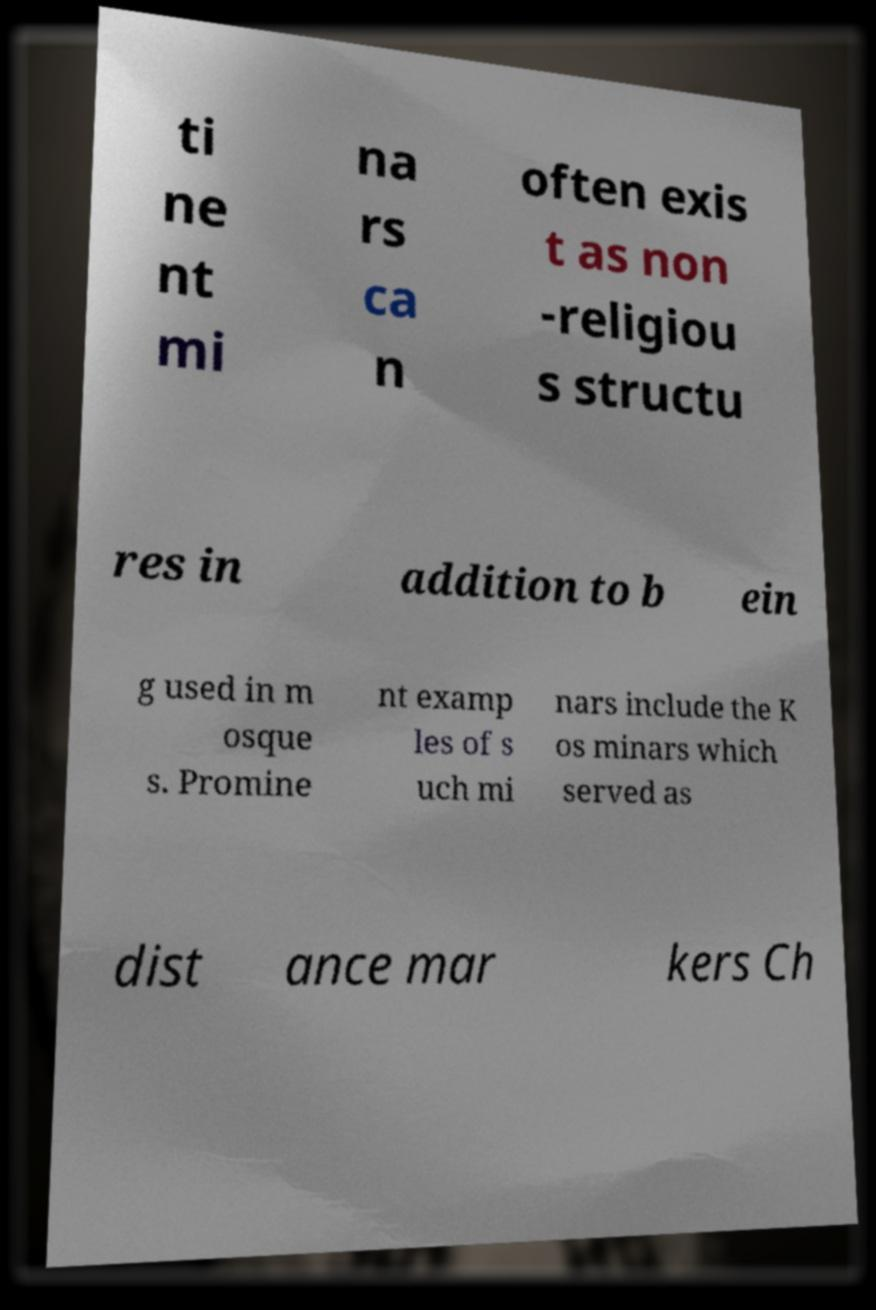Please read and relay the text visible in this image. What does it say? ti ne nt mi na rs ca n often exis t as non -religiou s structu res in addition to b ein g used in m osque s. Promine nt examp les of s uch mi nars include the K os minars which served as dist ance mar kers Ch 